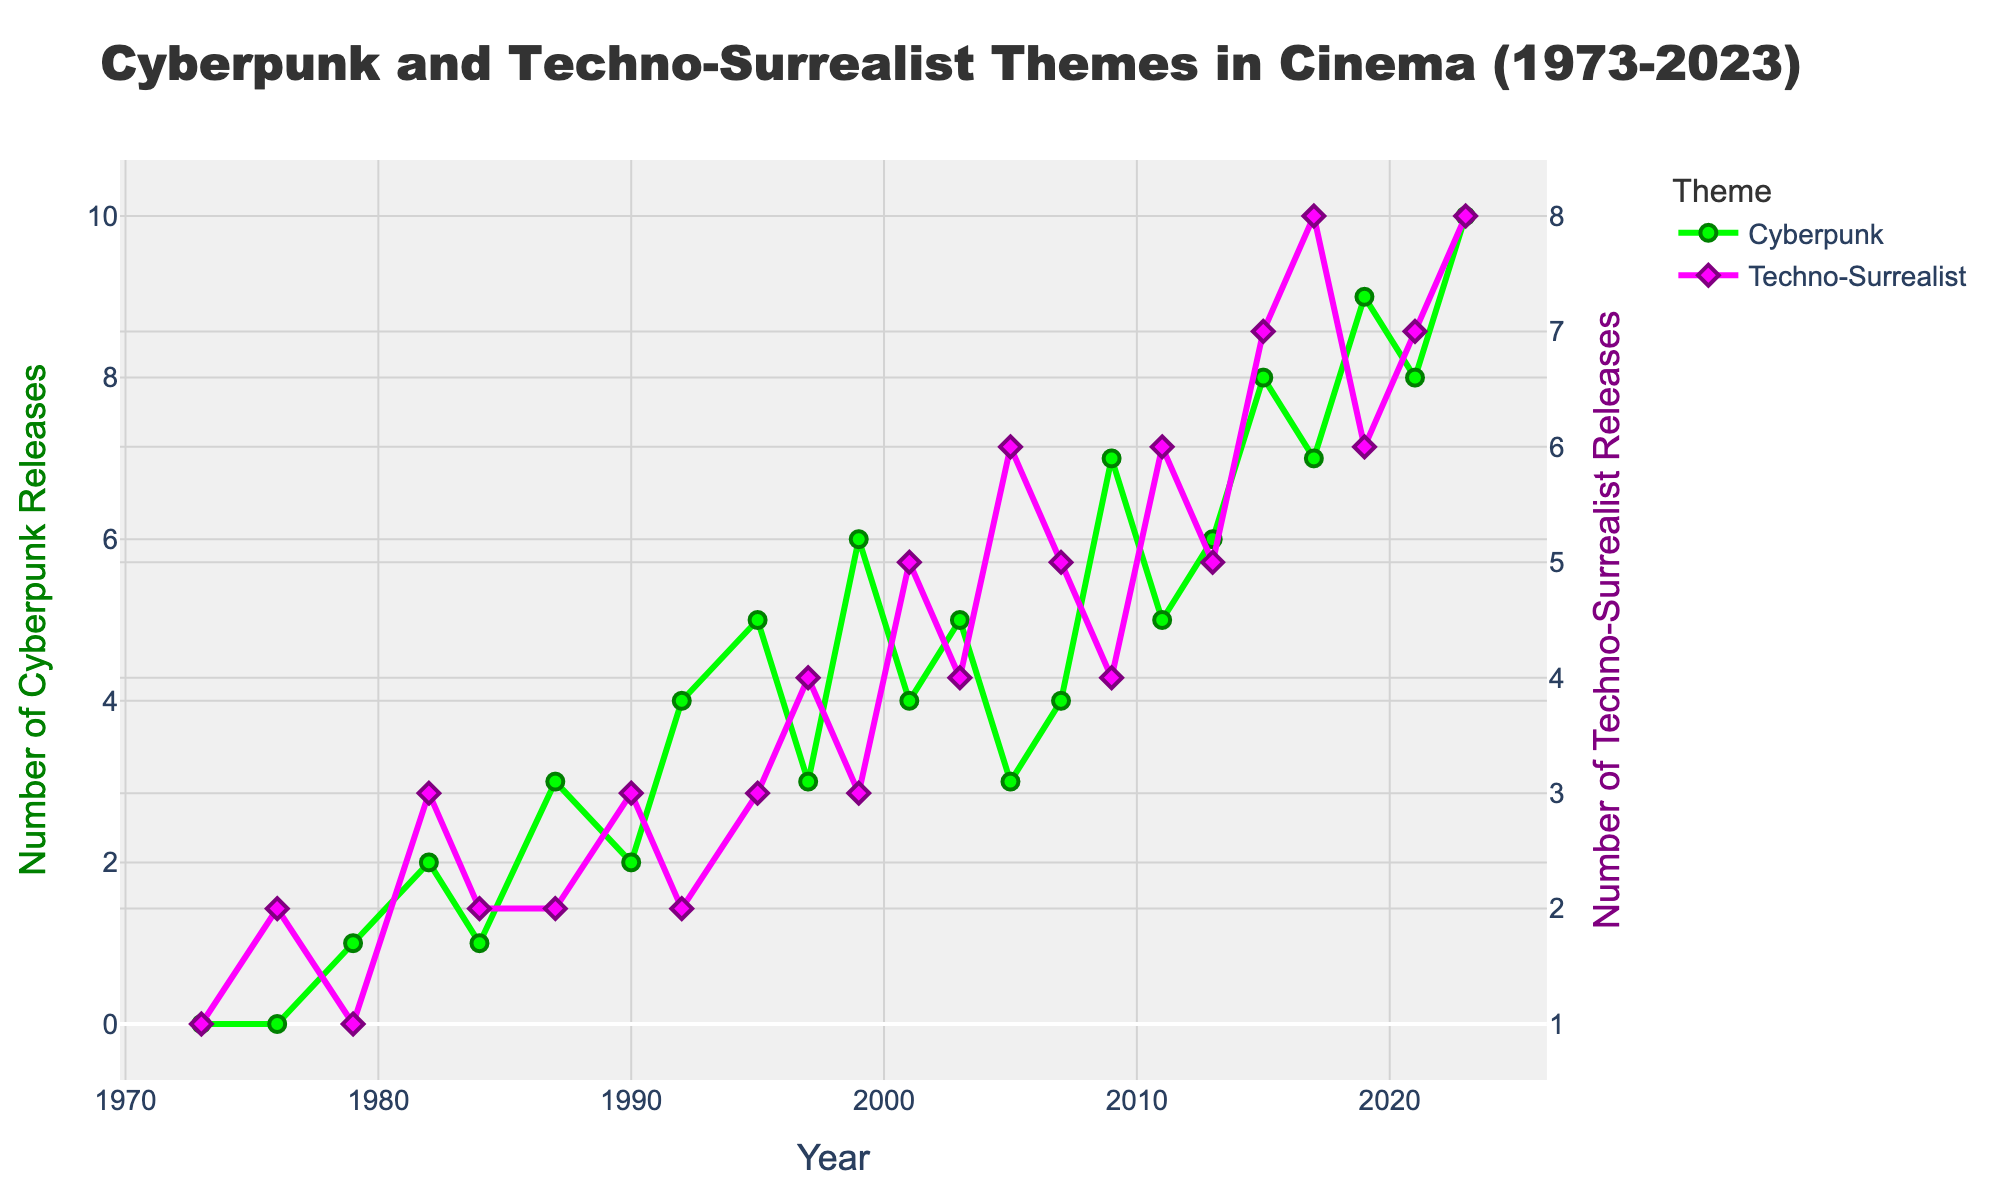What's the highest number of Cyberpunk releases in a single year? Look at the peak of the green line in the figure. The highest point is in 2023 where the number reaches 10.
Answer: 10 Which year had more Techno-Surrealist releases, 2005 or 2021? Look at the purple line in the figure at the years 2005 and 2021. In 2005, there were 6 releases, and in 2021, there were 7.
Answer: 2021 During which year did Cyberpunk see its first increase, and by how much compared to the previous year? Examine the green line for the first upward movement between consecutive years. The first increase is between 1979 and 1982, rising from 1 to 2 releases, an increase of 1.
Answer: 1982, by 1 What is the combined total of Cyberpunk and Techno-Surrealist releases in the year 2015? Add the values for both Cyberpunk and Techno-Surrealist in 2015. There were 8 Cyberpunk releases and 7 Techno-Surrealist releases: 8 + 7 = 15.
Answer: 15 How many years show an equal number of Cyberpunk and Techno-Surrealist releases? Compare the green and purple lines for intersections. The years where both have equal releases are 1979, 1987, 1999, 2003, 2017.
Answer: 5 In which decade did Techno-Surrealist themes see the most consistent growth? Observe the trend of the purple line over different decades. The most consistent growth appears in the 2000s, with steady increases from 2001 to 2023.
Answer: 2000s Calculate the average number of Cyberpunk releases per year for the years 1990, 1992, and 1995. Sum up the Cyberpunk releases for the years 1990, 1992, and 1995: 2 + 4 + 5 = 11. Then, divide by the number of years (3): 11 / 3 ≈ 3.67.
Answer: 3.67 Which theme, Cyberpunk or Techno-Surrealist, had a higher growth rate between 2015 and 2017? For Cyberpunk, from 8 in 2015 to 7 in 2017, there's no growth. For Techno-Surrealist, from 7 in 2015 to 8 in 2017, there's an increase of 1. Hence, Techno-Surrealist had a higher growth rate.
Answer: Techno-Surrealist In which year did Cyberpunk releases surpass Techno-Surrealist releases for the first time? Find the first year when the green line (Cyberpunk) goes above the purple line (Techno-Surrealist). This occurs in 1992, with 4 Cyberpunk and 2 Techno-Surrealist releases.
Answer: 1992 